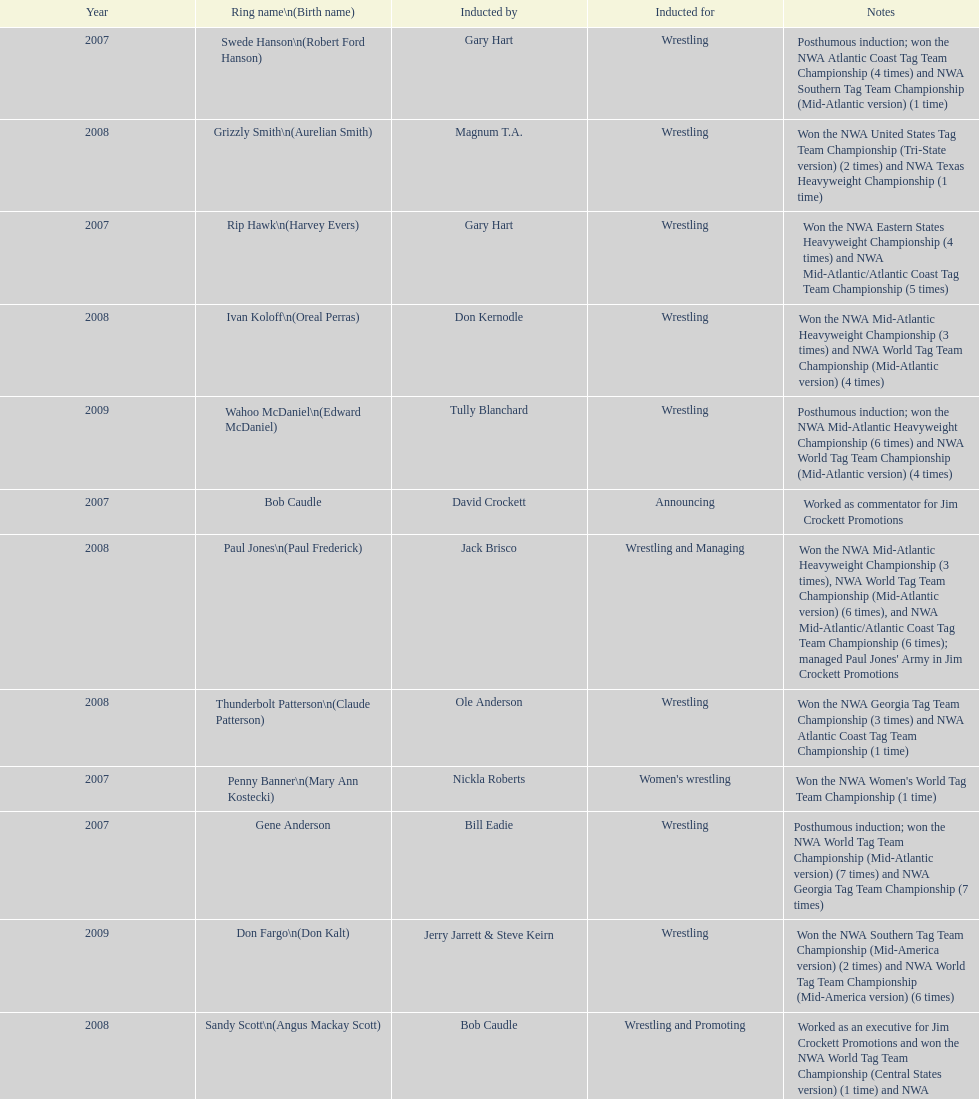Would you be able to parse every entry in this table? {'header': ['Year', 'Ring name\\n(Birth name)', 'Inducted by', 'Inducted for', 'Notes'], 'rows': [['2007', 'Swede Hanson\\n(Robert Ford Hanson)', 'Gary Hart', 'Wrestling', 'Posthumous induction; won the NWA Atlantic Coast Tag Team Championship (4 times) and NWA Southern Tag Team Championship (Mid-Atlantic version) (1 time)'], ['2008', 'Grizzly Smith\\n(Aurelian Smith)', 'Magnum T.A.', 'Wrestling', 'Won the NWA United States Tag Team Championship (Tri-State version) (2 times) and NWA Texas Heavyweight Championship (1 time)'], ['2007', 'Rip Hawk\\n(Harvey Evers)', 'Gary Hart', 'Wrestling', 'Won the NWA Eastern States Heavyweight Championship (4 times) and NWA Mid-Atlantic/Atlantic Coast Tag Team Championship (5 times)'], ['2008', 'Ivan Koloff\\n(Oreal Perras)', 'Don Kernodle', 'Wrestling', 'Won the NWA Mid-Atlantic Heavyweight Championship (3 times) and NWA World Tag Team Championship (Mid-Atlantic version) (4 times)'], ['2009', 'Wahoo McDaniel\\n(Edward McDaniel)', 'Tully Blanchard', 'Wrestling', 'Posthumous induction; won the NWA Mid-Atlantic Heavyweight Championship (6 times) and NWA World Tag Team Championship (Mid-Atlantic version) (4 times)'], ['2007', 'Bob Caudle', 'David Crockett', 'Announcing', 'Worked as commentator for Jim Crockett Promotions'], ['2008', 'Paul Jones\\n(Paul Frederick)', 'Jack Brisco', 'Wrestling and Managing', "Won the NWA Mid-Atlantic Heavyweight Championship (3 times), NWA World Tag Team Championship (Mid-Atlantic version) (6 times), and NWA Mid-Atlantic/Atlantic Coast Tag Team Championship (6 times); managed Paul Jones' Army in Jim Crockett Promotions"], ['2008', 'Thunderbolt Patterson\\n(Claude Patterson)', 'Ole Anderson', 'Wrestling', 'Won the NWA Georgia Tag Team Championship (3 times) and NWA Atlantic Coast Tag Team Championship (1 time)'], ['2007', 'Penny Banner\\n(Mary Ann Kostecki)', 'Nickla Roberts', "Women's wrestling", "Won the NWA Women's World Tag Team Championship (1 time)"], ['2007', 'Gene Anderson', 'Bill Eadie', 'Wrestling', 'Posthumous induction; won the NWA World Tag Team Championship (Mid-Atlantic version) (7 times) and NWA Georgia Tag Team Championship (7 times)'], ['2009', 'Don Fargo\\n(Don Kalt)', 'Jerry Jarrett & Steve Keirn', 'Wrestling', 'Won the NWA Southern Tag Team Championship (Mid-America version) (2 times) and NWA World Tag Team Championship (Mid-America version) (6 times)'], ['2008', 'Sandy Scott\\n(Angus Mackay Scott)', 'Bob Caudle', 'Wrestling and Promoting', 'Worked as an executive for Jim Crockett Promotions and won the NWA World Tag Team Championship (Central States version) (1 time) and NWA Southern Tag Team Championship (Mid-Atlantic version) (3 times)'], ['2009', 'Gary Hart\\n(Gary Williams)', 'Sir Oliver Humperdink', 'Managing and Promoting', 'Posthumous induction; worked as a booker in World Class Championship Wrestling and managed several wrestlers in Mid-Atlantic Championship Wrestling'], ['2007', 'George Scott', 'Tommy Young', 'Wrestling and Promoting', 'Won the NWA Southern Tag Team Championship (Mid-Atlantic version) (2 times) and worked as booker for Jim Crockett Promotions'], ['2009', 'Blackjack Mulligan\\n(Robert Windham)', 'Ric Flair', 'Wrestling', 'Won the NWA Texas Heavyweight Championship (1 time) and NWA World Tag Team Championship (Mid-Atlantic version) (1 time)'], ['2009', 'Lance Russell', 'Dave Brown', 'Announcing', 'Worked as commentator for wrestling events in the Memphis area'], ['2009', 'Sonny Fargo\\n(Jack Lewis Faggart)', 'Jerry Jarrett & Steve Keirn', 'Wrestling', 'Posthumous induction; won the NWA Southern Tag Team Championship (Mid-America version) (3 times)'], ['2007', 'Ole Anderson\\n(Alan Rogowski)', 'Bill Eadie', 'Wrestling', 'Won the NWA Mid-Atlantic/Atlantic Coast Tag Team Championship (7 times) and NWA World Tag Team Championship (Mid-Atlantic version) (8 times)'], ['2009', 'Jackie Fargo\\n(Henry Faggart)', 'Jerry Jarrett & Steve Keirn', 'Wrestling', 'Won the NWA World Tag Team Championship (Mid-America version) (10 times) and NWA Southern Tag Team Championship (Mid-America version) (22 times)'], ['2009', 'Nelson Royal', 'Brad Anderson, Tommy Angel & David Isley', 'Wrestling', 'Won the NWA Atlantic Coast Tag Team Championship (2 times)'], ['2008', 'Johnny Weaver\\n(Kenneth Eugene Weaver)', 'Rip Hawk', 'Wrestling', 'Posthumous induction; won the NWA Atlantic Coast/Mid-Atlantic Tag Team Championship (8 times) and NWA Southern Tag Team Championship (Mid-Atlantic version) (6 times)'], ['2008', 'Buddy Roberts\\n(Dale Hey)', 'Jimmy Garvin and Michael Hayes', 'Wrestling', 'Won the NWA World Six-Man Tag Team Championship (Texas version) / WCWA World Six-Man Tag Team Championship (6 times) and NWA Mid-Atlantic Tag Team Championship (1 time)']]} Bob caudle was an announcer, who was the other one? Lance Russell. 